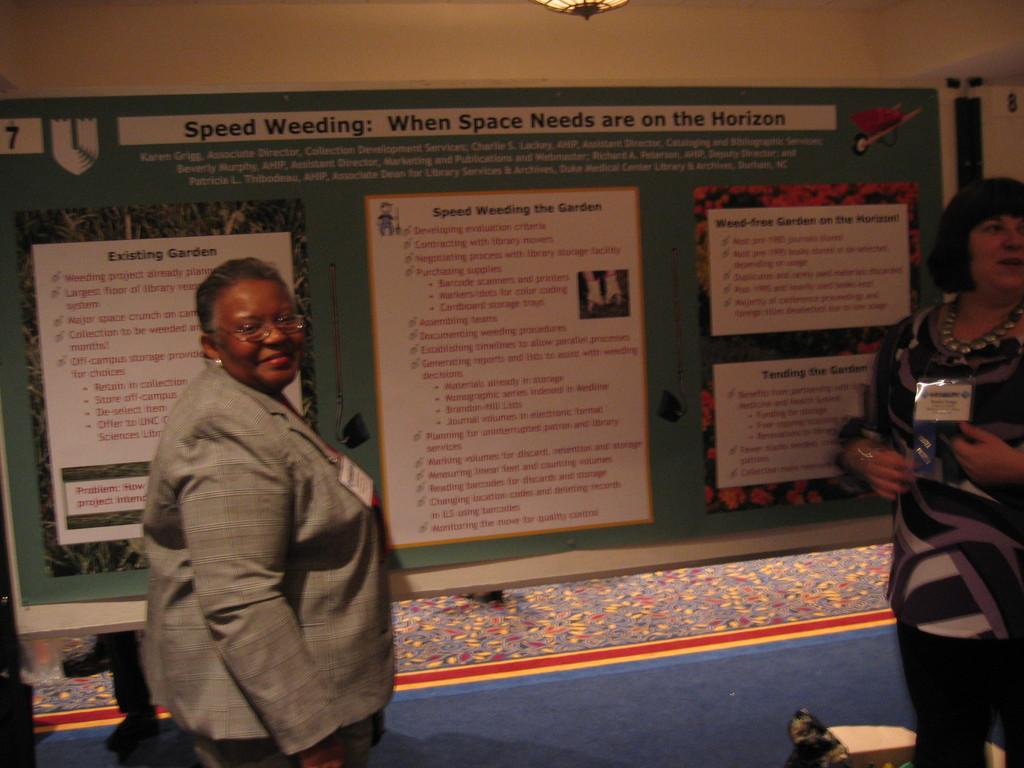How would you summarize this image in a sentence or two? In this image, we can see two women are standing and smiling. They are wearing batches. Background there is a board. We can see poster. At the bottom, there is a blue color. Top of the image, we can see the light. 